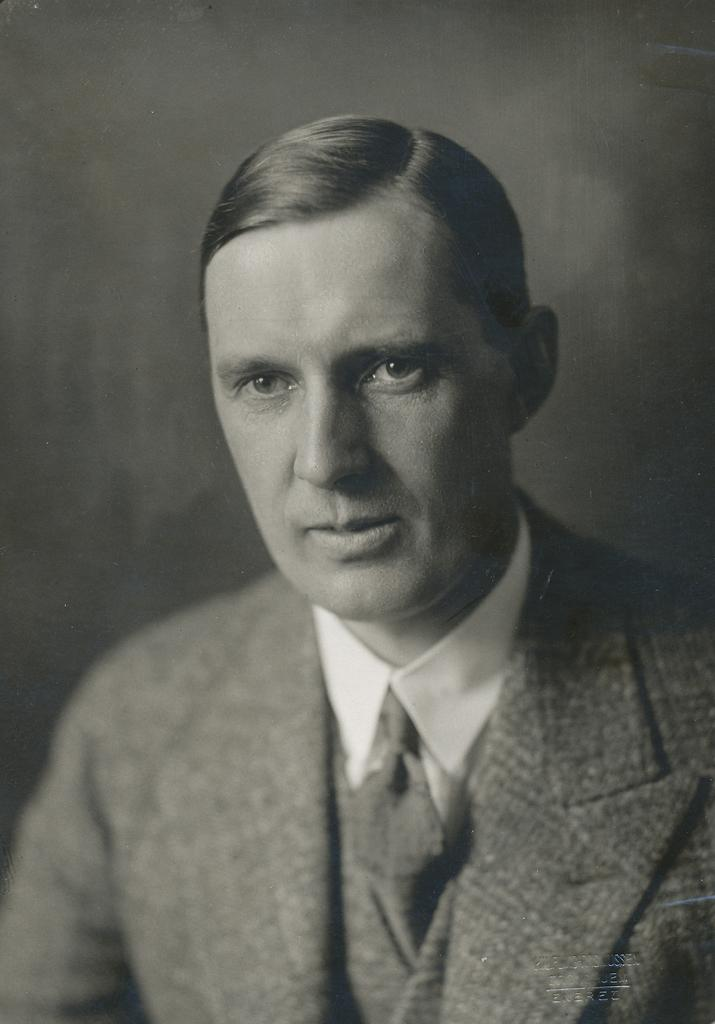What is the color scheme of the image? The image is black and white. Can you describe the main subject of the image? There is a man in the image. Is there any additional information or markings in the image? Yes, there is a watermark in the right bottom corner of the image. What type of oil is being spilled in the image? There is no oil being spilled in the image; it is a black and white image featuring a man and a watermark. How does the man cope with his loss in the image? There is no indication of loss or any emotional state in the image; it simply shows a man and a watermark. 